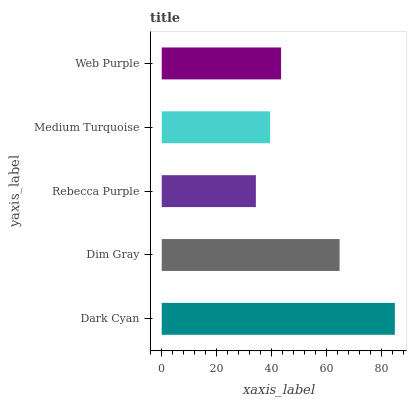Is Rebecca Purple the minimum?
Answer yes or no. Yes. Is Dark Cyan the maximum?
Answer yes or no. Yes. Is Dim Gray the minimum?
Answer yes or no. No. Is Dim Gray the maximum?
Answer yes or no. No. Is Dark Cyan greater than Dim Gray?
Answer yes or no. Yes. Is Dim Gray less than Dark Cyan?
Answer yes or no. Yes. Is Dim Gray greater than Dark Cyan?
Answer yes or no. No. Is Dark Cyan less than Dim Gray?
Answer yes or no. No. Is Web Purple the high median?
Answer yes or no. Yes. Is Web Purple the low median?
Answer yes or no. Yes. Is Dim Gray the high median?
Answer yes or no. No. Is Dark Cyan the low median?
Answer yes or no. No. 